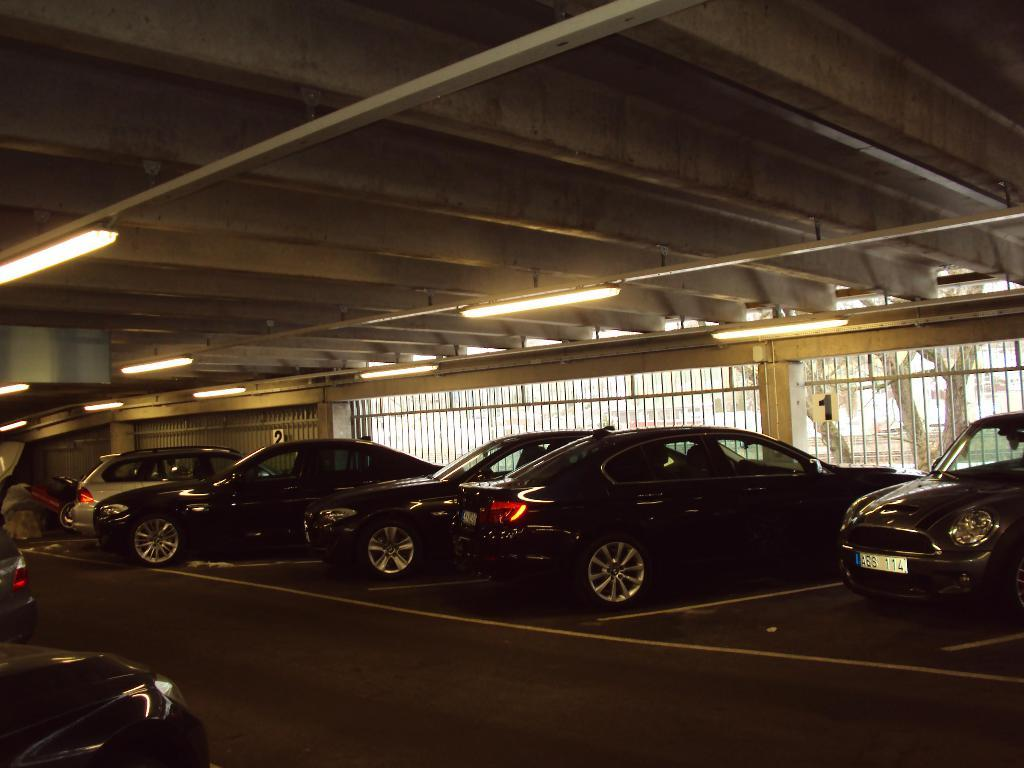What can be seen in the image related to vehicles? There are cars parked in the image. Where are the cars located? The cars are in a parking place. What type of lighting is present in the parking place? There are tube lights attached to the wall above the parking place. What can be seen in the background of the image? There is a fence in the background of the image. How many apples are hanging from the fence in the image? There are no apples present in the image, and therefore no apples can be seen hanging from the fence. 